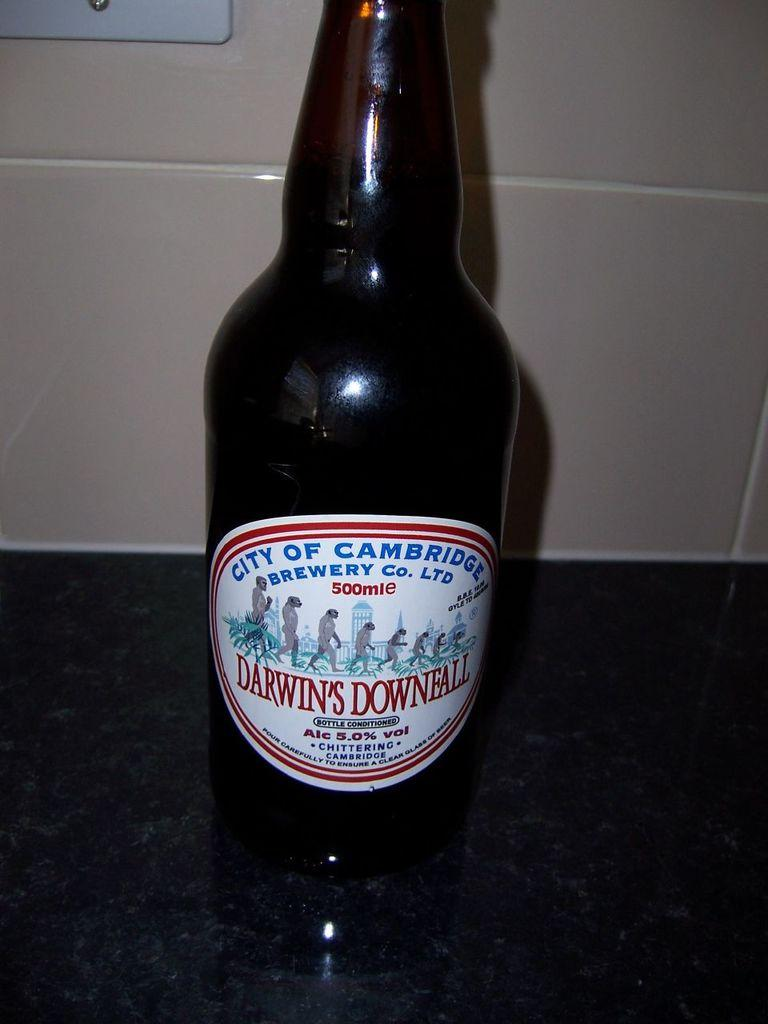<image>
Describe the image concisely. Bottle of Darwin's Downfall brewery beer that contains alcohol 